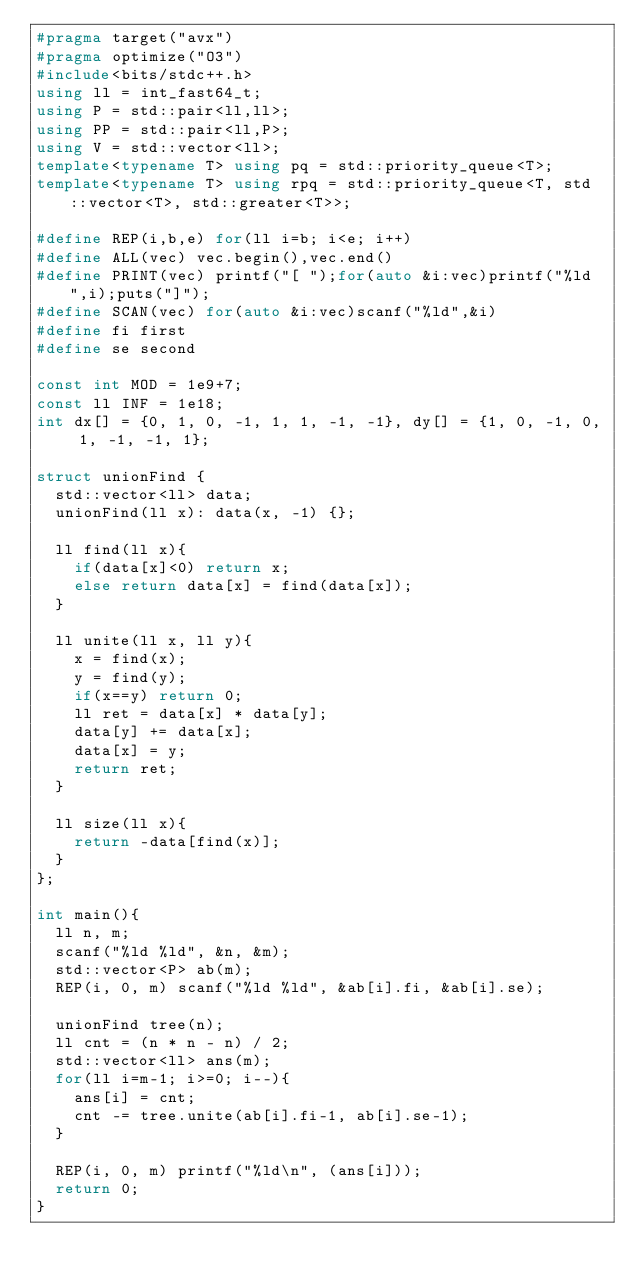Convert code to text. <code><loc_0><loc_0><loc_500><loc_500><_C++_>#pragma target("avx")
#pragma optimize("O3")
#include<bits/stdc++.h>
using ll = int_fast64_t;
using P = std::pair<ll,ll>;
using PP = std::pair<ll,P>;
using V = std::vector<ll>;
template<typename T> using pq = std::priority_queue<T>;
template<typename T> using rpq = std::priority_queue<T, std::vector<T>, std::greater<T>>;

#define REP(i,b,e) for(ll i=b; i<e; i++)
#define ALL(vec) vec.begin(),vec.end()
#define PRINT(vec) printf("[ ");for(auto &i:vec)printf("%ld ",i);puts("]");
#define SCAN(vec) for(auto &i:vec)scanf("%ld",&i)
#define fi first
#define se second

const int MOD = 1e9+7;
const ll INF = 1e18;
int dx[] = {0, 1, 0, -1, 1, 1, -1, -1}, dy[] = {1, 0, -1, 0, 1, -1, -1, 1};

struct unionFind {
	std::vector<ll> data;
	unionFind(ll x): data(x, -1) {};

	ll find(ll x){
		if(data[x]<0) return x;
		else return data[x] = find(data[x]);
	}

	ll unite(ll x, ll y){
		x = find(x);
		y = find(y);
		if(x==y) return 0;
		ll ret = data[x] * data[y];
		data[y] += data[x];
		data[x] = y;
		return ret;
	}

	ll size(ll x){
		return -data[find(x)];
	}
};

int main(){
	ll n, m;
	scanf("%ld %ld", &n, &m);
	std::vector<P> ab(m);
	REP(i, 0, m) scanf("%ld %ld", &ab[i].fi, &ab[i].se);
	
	unionFind tree(n);
	ll cnt = (n * n - n) / 2;
	std::vector<ll> ans(m);
	for(ll i=m-1; i>=0; i--){
		ans[i] = cnt;
		cnt -= tree.unite(ab[i].fi-1, ab[i].se-1);
	}

	REP(i, 0, m) printf("%ld\n", (ans[i]));
	return 0;
}

</code> 